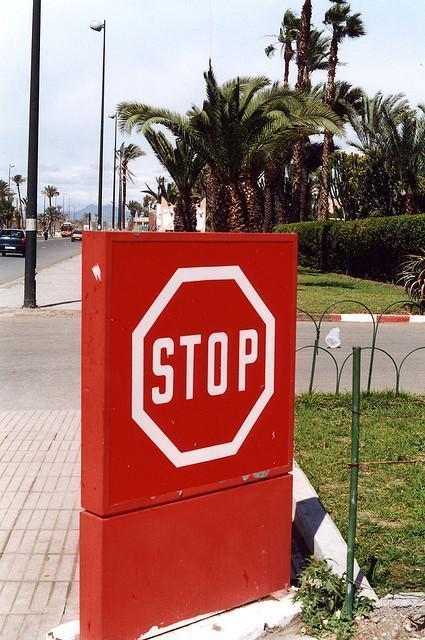How many people are wearing hats?
Give a very brief answer. 0. 